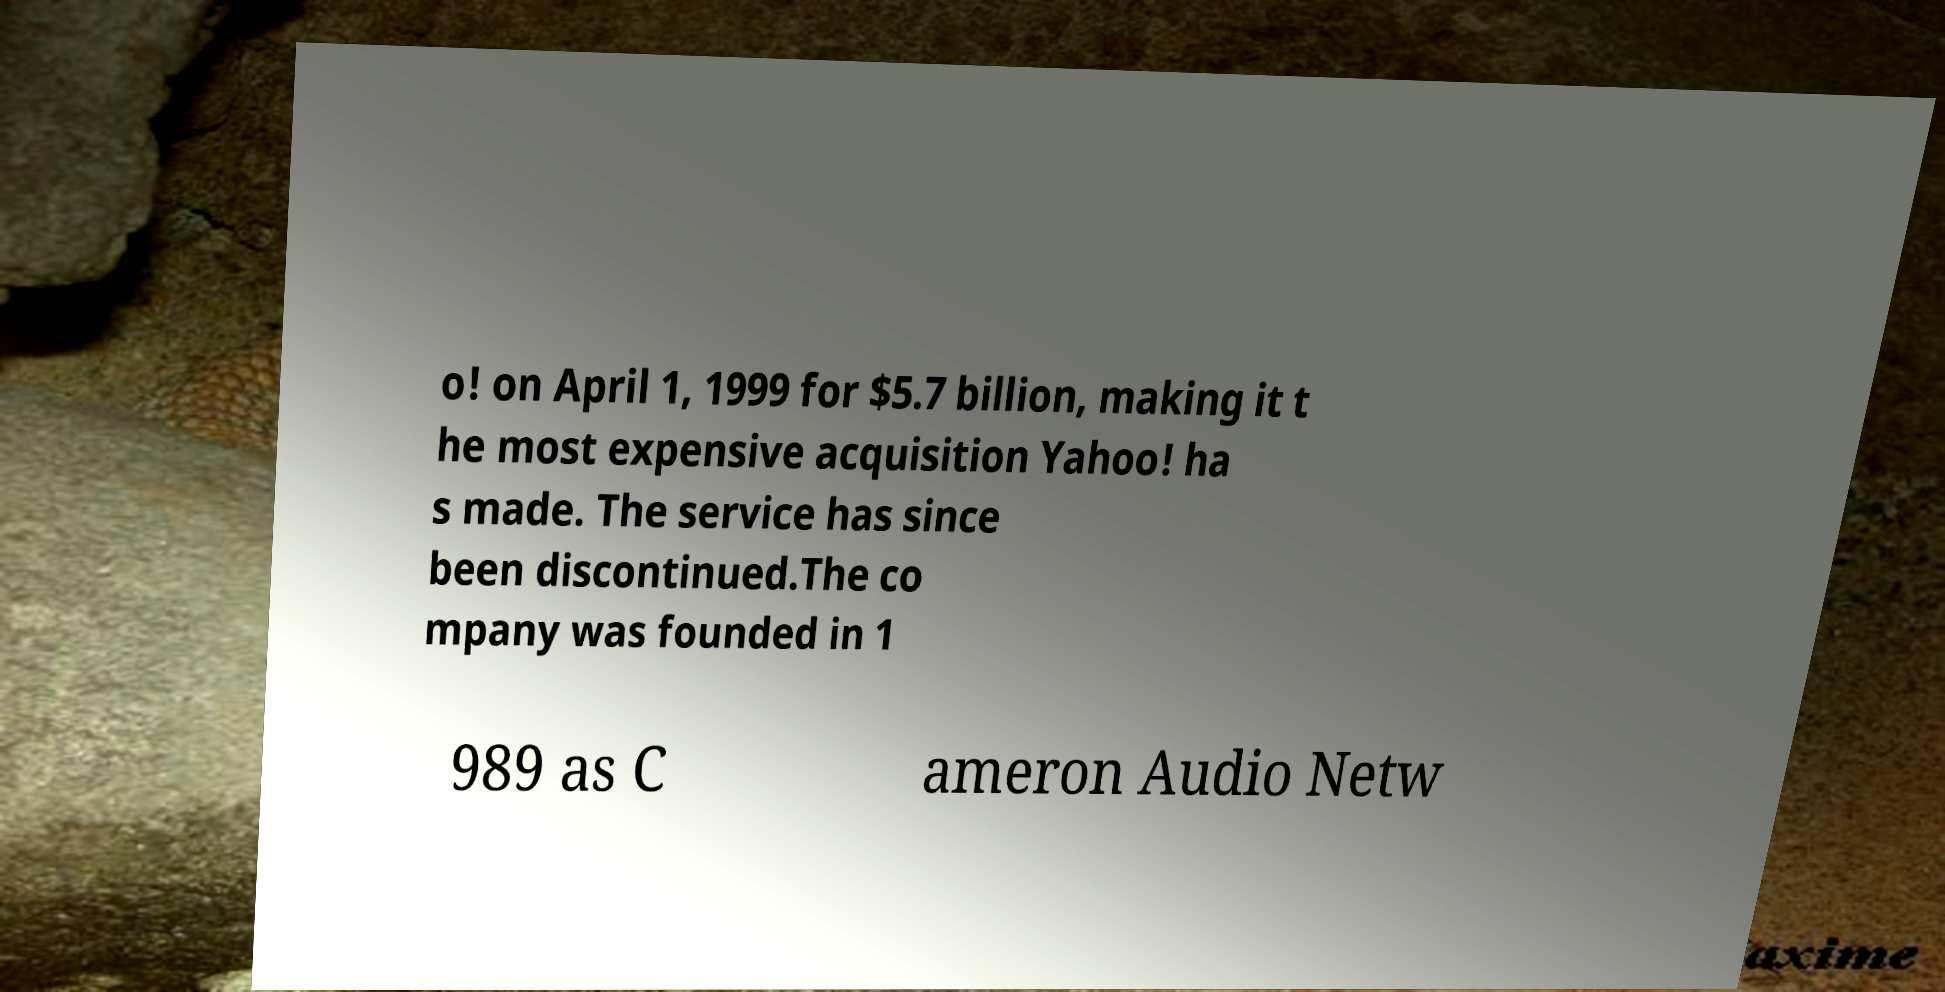Please identify and transcribe the text found in this image. o! on April 1, 1999 for $5.7 billion, making it t he most expensive acquisition Yahoo! ha s made. The service has since been discontinued.The co mpany was founded in 1 989 as C ameron Audio Netw 